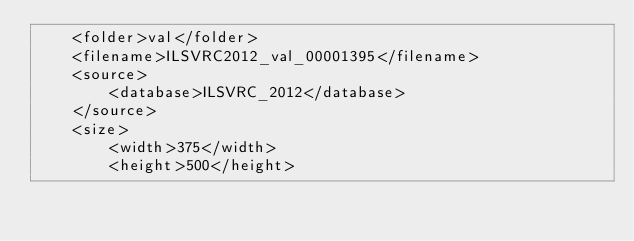<code> <loc_0><loc_0><loc_500><loc_500><_XML_>	<folder>val</folder>
	<filename>ILSVRC2012_val_00001395</filename>
	<source>
		<database>ILSVRC_2012</database>
	</source>
	<size>
		<width>375</width>
		<height>500</height></code> 